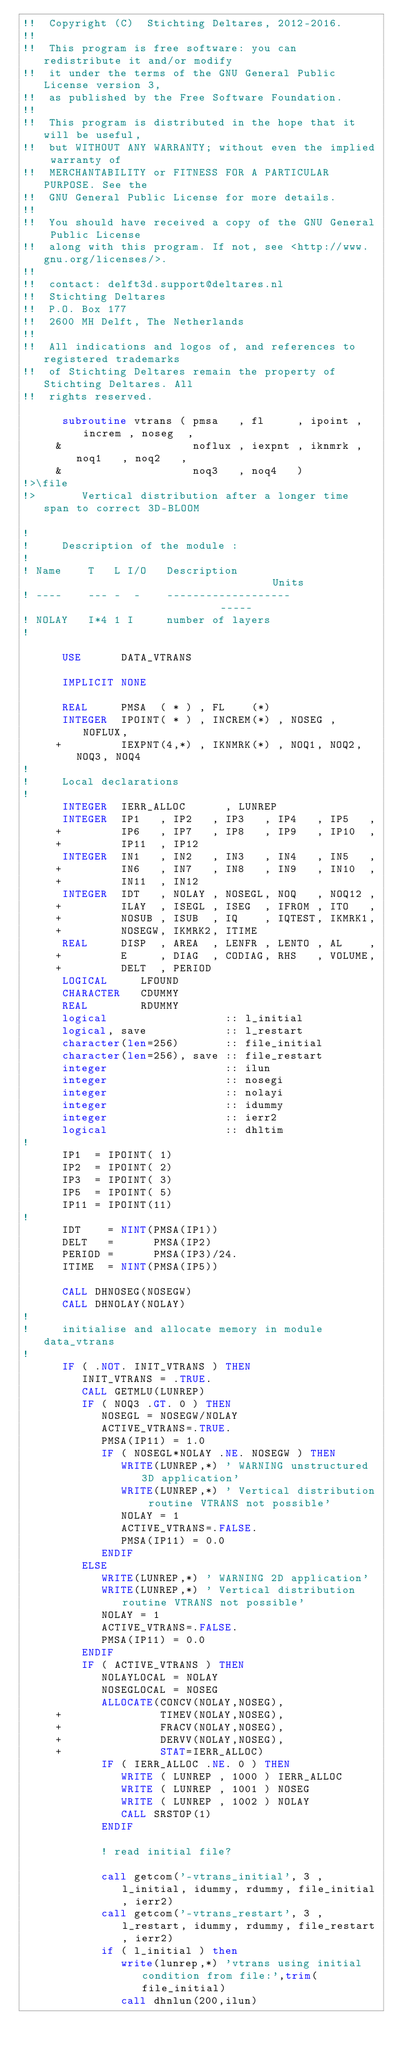Convert code to text. <code><loc_0><loc_0><loc_500><loc_500><_FORTRAN_>!!  Copyright (C)  Stichting Deltares, 2012-2016.
!!
!!  This program is free software: you can redistribute it and/or modify
!!  it under the terms of the GNU General Public License version 3,
!!  as published by the Free Software Foundation.
!!
!!  This program is distributed in the hope that it will be useful,
!!  but WITHOUT ANY WARRANTY; without even the implied warranty of
!!  MERCHANTABILITY or FITNESS FOR A PARTICULAR PURPOSE. See the
!!  GNU General Public License for more details.
!!
!!  You should have received a copy of the GNU General Public License
!!  along with this program. If not, see <http://www.gnu.org/licenses/>.
!!
!!  contact: delft3d.support@deltares.nl
!!  Stichting Deltares
!!  P.O. Box 177
!!  2600 MH Delft, The Netherlands
!!
!!  All indications and logos of, and references to registered trademarks
!!  of Stichting Deltares remain the property of Stichting Deltares. All
!!  rights reserved.

      subroutine vtrans ( pmsa   , fl     , ipoint , increm , noseg  ,
     &                    noflux , iexpnt , iknmrk , noq1   , noq2   ,
     &                    noq3   , noq4   )
!>\file
!>       Vertical distribution after a longer time span to correct 3D-BLOOM

!
!     Description of the module :
!
! Name    T   L I/O   Description                                    Units
! ----    --- -  -    -------------------                            -----
! NOLAY   I*4 1 I     number of layers
!

      USE      DATA_VTRANS

      IMPLICIT NONE

      REAL     PMSA  ( * ) , FL    (*)
      INTEGER  IPOINT( * ) , INCREM(*) , NOSEG , NOFLUX,
     +         IEXPNT(4,*) , IKNMRK(*) , NOQ1, NOQ2, NOQ3, NOQ4
!
!     Local declarations
!
      INTEGER  IERR_ALLOC      , LUNREP
      INTEGER  IP1   , IP2   , IP3   , IP4   , IP5   ,
     +         IP6   , IP7   , IP8   , IP9   , IP10  ,
     +         IP11  , IP12
      INTEGER  IN1   , IN2   , IN3   , IN4   , IN5   ,
     +         IN6   , IN7   , IN8   , IN9   , IN10  ,
     +         IN11  , IN12
      INTEGER  IDT   , NOLAY , NOSEGL, NOQ   , NOQ12 ,
     +         ILAY  , ISEGL , ISEG  , IFROM , ITO   ,
     +         NOSUB , ISUB  , IQ    , IQTEST, IKMRK1,
     +         NOSEGW, IKMRK2, ITIME
      REAL     DISP  , AREA  , LENFR , LENTO , AL    ,
     +         E     , DIAG  , CODIAG, RHS   , VOLUME,
     +         DELT  , PERIOD
      LOGICAL     LFOUND
      CHARACTER   CDUMMY
      REAL        RDUMMY
      logical                  :: l_initial
      logical, save            :: l_restart
      character(len=256)       :: file_initial
      character(len=256), save :: file_restart
      integer                  :: ilun
      integer                  :: nosegi
      integer                  :: nolayi
      integer                  :: idummy
      integer                  :: ierr2
      logical                  :: dhltim
!
      IP1  = IPOINT( 1)
      IP2  = IPOINT( 2)
      IP3  = IPOINT( 3)
      IP5  = IPOINT( 5)
      IP11 = IPOINT(11)
!
      IDT    = NINT(PMSA(IP1))
      DELT   =      PMSA(IP2)
      PERIOD =      PMSA(IP3)/24.
      ITIME  = NINT(PMSA(IP5))

      CALL DHNOSEG(NOSEGW)
      CALL DHNOLAY(NOLAY)
!
!     initialise and allocate memory in module data_vtrans
!
      IF ( .NOT. INIT_VTRANS ) THEN
         INIT_VTRANS = .TRUE.
         CALL GETMLU(LUNREP)
         IF ( NOQ3 .GT. 0 ) THEN
            NOSEGL = NOSEGW/NOLAY
            ACTIVE_VTRANS=.TRUE.
            PMSA(IP11) = 1.0
            IF ( NOSEGL*NOLAY .NE. NOSEGW ) THEN
               WRITE(LUNREP,*) ' WARNING unstructured 3D application'
               WRITE(LUNREP,*) ' Vertical distribution routine VTRANS not possible'
               NOLAY = 1
               ACTIVE_VTRANS=.FALSE.
               PMSA(IP11) = 0.0
            ENDIF
         ELSE
            WRITE(LUNREP,*) ' WARNING 2D application'
            WRITE(LUNREP,*) ' Vertical distribution routine VTRANS not possible'
            NOLAY = 1
            ACTIVE_VTRANS=.FALSE.
            PMSA(IP11) = 0.0
         ENDIF
         IF ( ACTIVE_VTRANS ) THEN
            NOLAYLOCAL = NOLAY
            NOSEGLOCAL = NOSEG
            ALLOCATE(CONCV(NOLAY,NOSEG),
     +               TIMEV(NOLAY,NOSEG),
     +               FRACV(NOLAY,NOSEG),
     +               DERVV(NOLAY,NOSEG),
     +               STAT=IERR_ALLOC)
            IF ( IERR_ALLOC .NE. 0 ) THEN
               WRITE ( LUNREP , 1000 ) IERR_ALLOC
               WRITE ( LUNREP , 1001 ) NOSEG
               WRITE ( LUNREP , 1002 ) NOLAY
               CALL SRSTOP(1)
            ENDIF

            ! read initial file?

            call getcom('-vtrans_initial', 3 , l_initial, idummy, rdummy, file_initial, ierr2)
            call getcom('-vtrans_restart', 3 , l_restart, idummy, rdummy, file_restart, ierr2)
            if ( l_initial ) then
               write(lunrep,*) 'vtrans using initial condition from file:',trim(file_initial)
               call dhnlun(200,ilun)</code> 